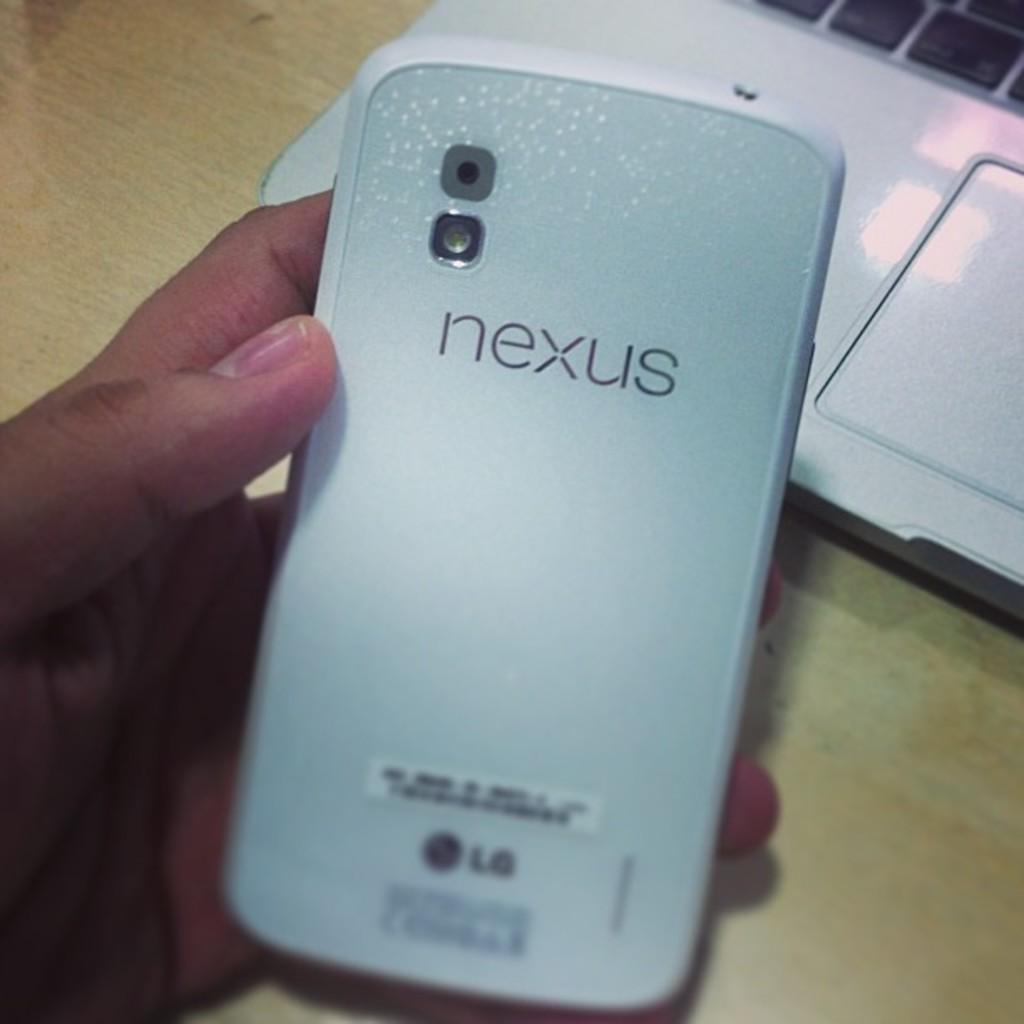What object is being held in the image? There is a cell phone in the image, and it is being held in someone's hand. What might be the purpose of holding the cell phone? The purpose of holding the cell phone could be to make a call, send a message, or use an app. What is located behind the cell phone in the image? There appears to be a box behind the cell phone. What is the condition of the pull in the image? There is no pull present in the image. 